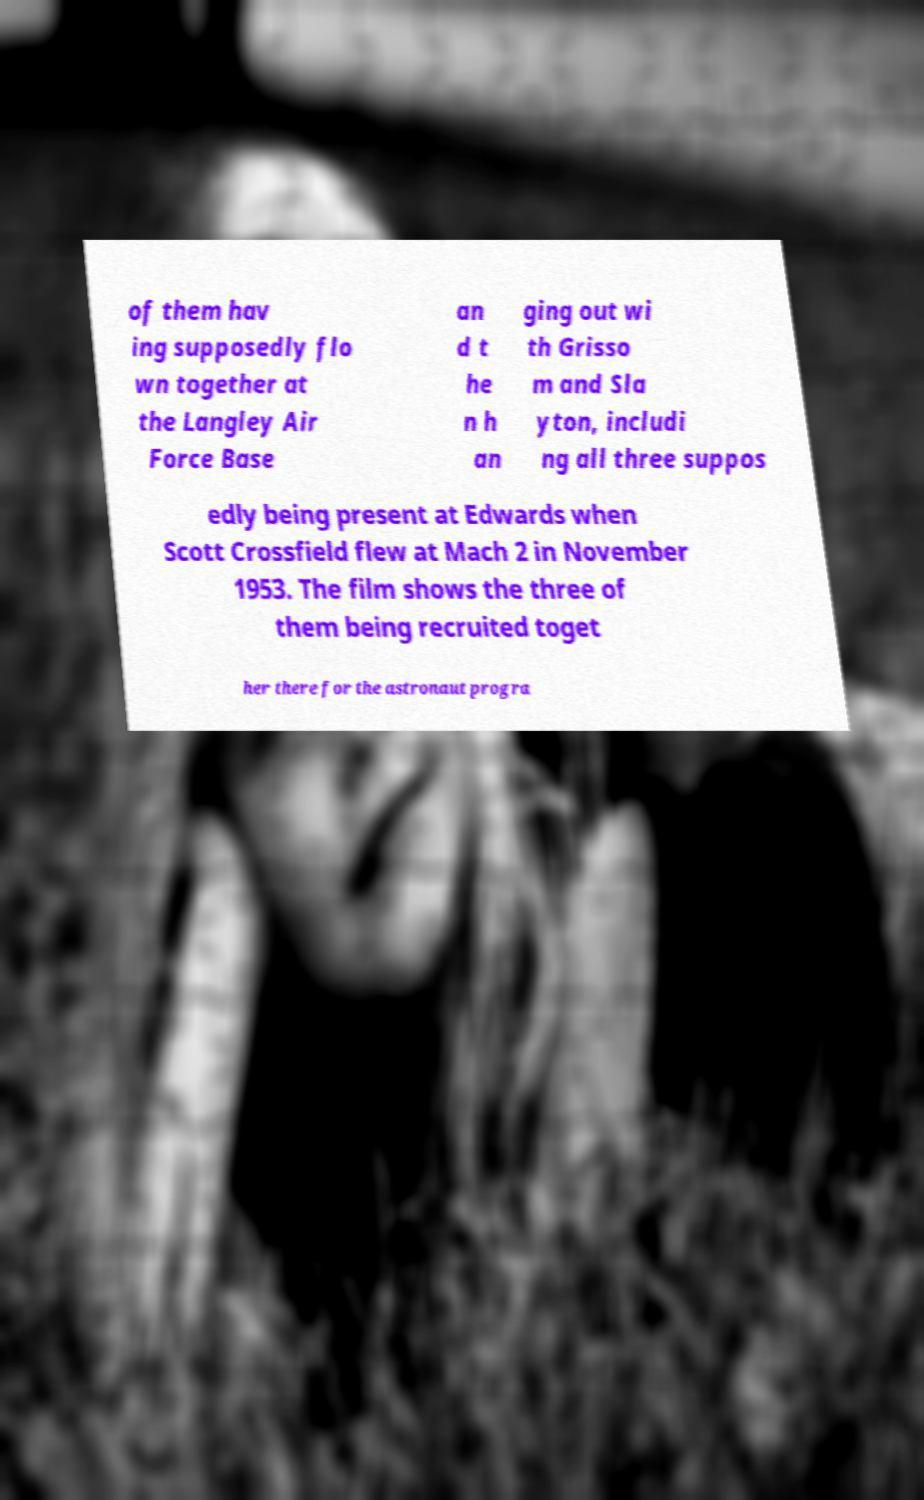Could you assist in decoding the text presented in this image and type it out clearly? of them hav ing supposedly flo wn together at the Langley Air Force Base an d t he n h an ging out wi th Grisso m and Sla yton, includi ng all three suppos edly being present at Edwards when Scott Crossfield flew at Mach 2 in November 1953. The film shows the three of them being recruited toget her there for the astronaut progra 